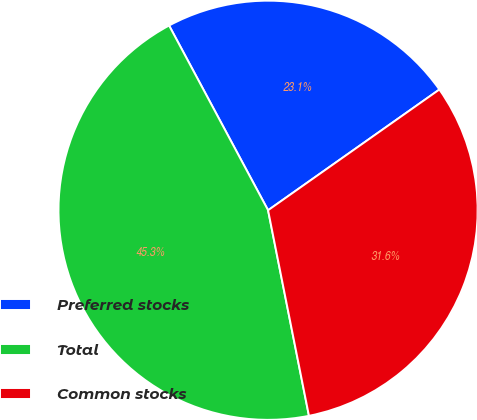<chart> <loc_0><loc_0><loc_500><loc_500><pie_chart><fcel>Preferred stocks<fcel>Total<fcel>Common stocks<nl><fcel>23.06%<fcel>45.3%<fcel>31.65%<nl></chart> 